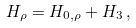<formula> <loc_0><loc_0><loc_500><loc_500>H _ { \rho } = H _ { 0 , \rho } + H _ { 3 } \, ,</formula> 